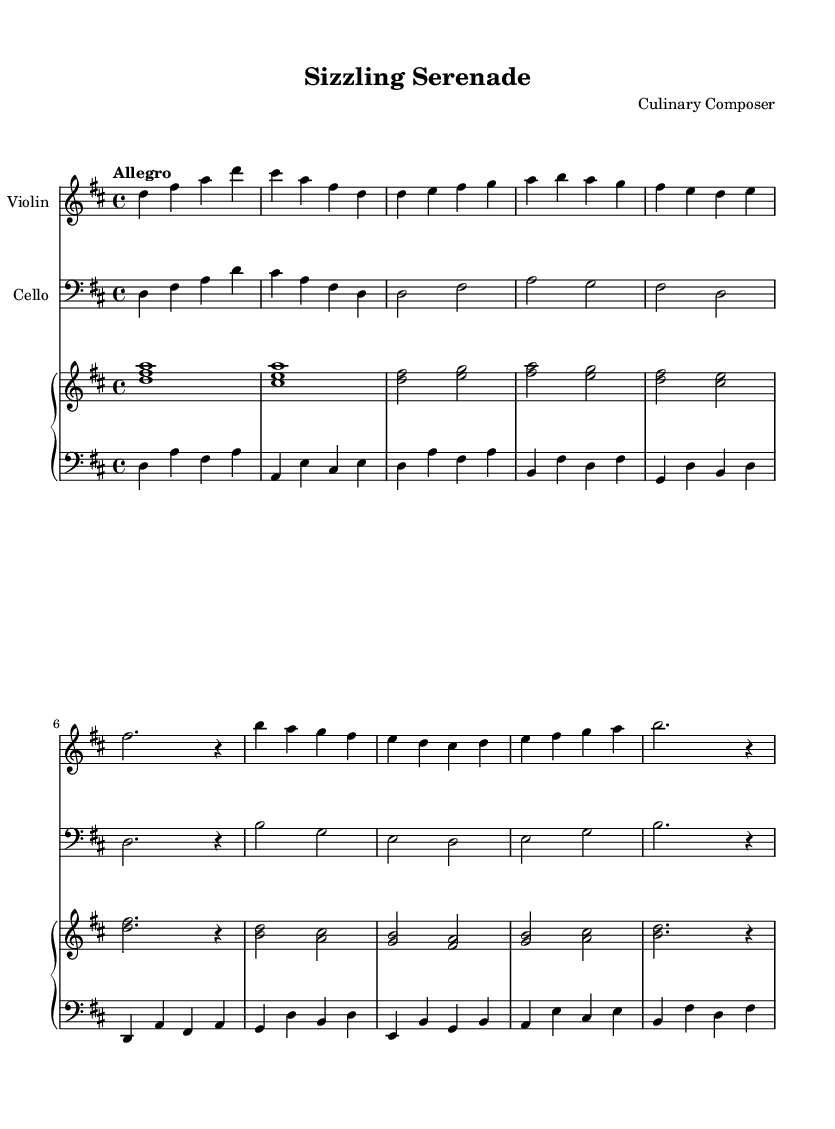What is the key signature of this piece? The key signature shown has two sharps, indicating that the piece is in the key of D major.
Answer: D major What is the time signature of this composition? The time signature is indicated as 4/4, which means there are four beats in each measure.
Answer: 4/4 What is the tempo marking for this music? The tempo marking at the beginning of the piece indicates "Allegro," suggesting that it should be played fast and lively.
Answer: Allegro How many musical themes are presented in this piece? Analyzing the structure, there are two distinct musical themes labeled as Theme A and Theme B, indicating a total of two themes.
Answer: Two What is the instrument associated with the top staff in the score? The top staff is labeled as "Violin," which indicates that it is for the violin instrument.
Answer: Violin Which section has the longest note values in the violin part? The longest note values are found in the introduction of the violin part, where it includes whole notes and half notes, specifically d4 and d2.
Answer: Introduction How many measures are in Theme A for the cello? Theme A for the cello consists of four measures, as counted through the music notation in the designated theme section.
Answer: Four 